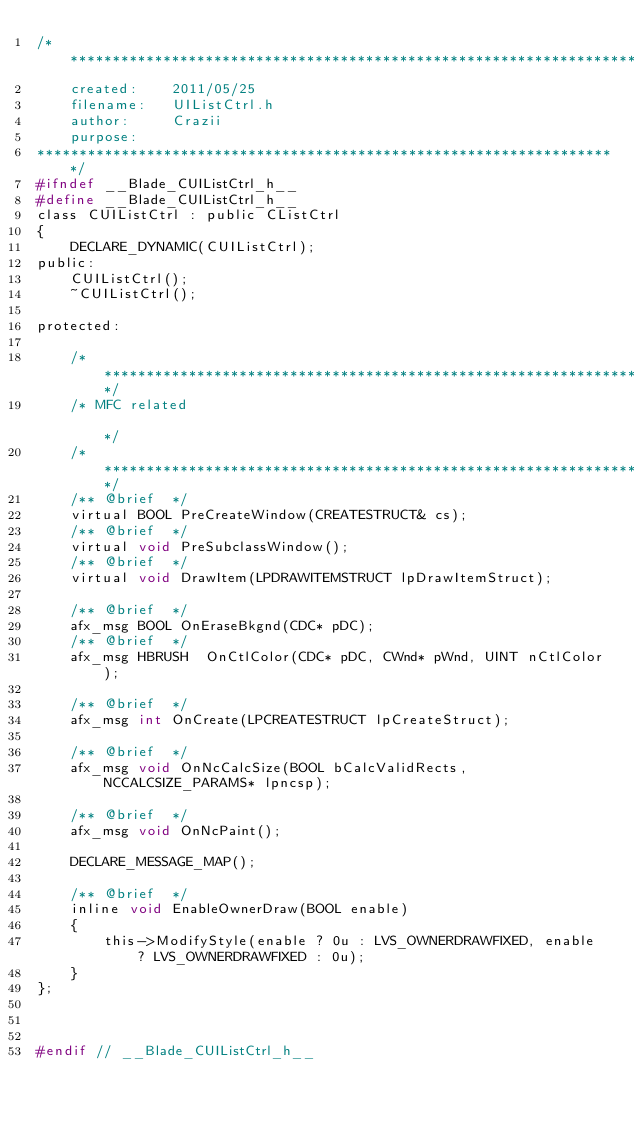<code> <loc_0><loc_0><loc_500><loc_500><_C_>/********************************************************************
	created:	2011/05/25
	filename: 	UIListCtrl.h
	author:		Crazii
	purpose:	
*********************************************************************/
#ifndef __Blade_CUIListCtrl_h__
#define __Blade_CUIListCtrl_h__
class CUIListCtrl : public CListCtrl
{
	DECLARE_DYNAMIC(CUIListCtrl);
public:
	CUIListCtrl();
	~CUIListCtrl();

protected:

	/************************************************************************/
	/* MFC related                                                                     */
	/************************************************************************/
	/** @brief  */
	virtual BOOL PreCreateWindow(CREATESTRUCT& cs);
	/** @brief  */
	virtual void PreSubclassWindow();
	/** @brief  */
	virtual void DrawItem(LPDRAWITEMSTRUCT lpDrawItemStruct);

	/** @brief  */
	afx_msg BOOL OnEraseBkgnd(CDC* pDC);
	/** @brief  */
	afx_msg HBRUSH  OnCtlColor(CDC* pDC, CWnd* pWnd, UINT nCtlColor);

	/** @brief  */
	afx_msg int OnCreate(LPCREATESTRUCT lpCreateStruct);

	/** @brief  */
	afx_msg	void OnNcCalcSize(BOOL bCalcValidRects, NCCALCSIZE_PARAMS* lpncsp);

	/** @brief  */
	afx_msg void OnNcPaint();

	DECLARE_MESSAGE_MAP();

	/** @brief  */
	inline void EnableOwnerDraw(BOOL enable)
	{
		this->ModifyStyle(enable ? 0u : LVS_OWNERDRAWFIXED, enable ? LVS_OWNERDRAWFIXED : 0u);
	}
};



#endif // __Blade_CUIListCtrl_h__</code> 